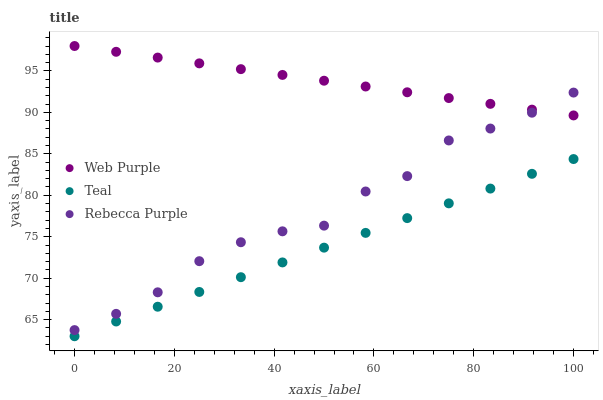Does Teal have the minimum area under the curve?
Answer yes or no. Yes. Does Web Purple have the maximum area under the curve?
Answer yes or no. Yes. Does Rebecca Purple have the minimum area under the curve?
Answer yes or no. No. Does Rebecca Purple have the maximum area under the curve?
Answer yes or no. No. Is Teal the smoothest?
Answer yes or no. Yes. Is Rebecca Purple the roughest?
Answer yes or no. Yes. Is Rebecca Purple the smoothest?
Answer yes or no. No. Is Teal the roughest?
Answer yes or no. No. Does Teal have the lowest value?
Answer yes or no. Yes. Does Rebecca Purple have the lowest value?
Answer yes or no. No. Does Web Purple have the highest value?
Answer yes or no. Yes. Does Rebecca Purple have the highest value?
Answer yes or no. No. Is Teal less than Rebecca Purple?
Answer yes or no. Yes. Is Rebecca Purple greater than Teal?
Answer yes or no. Yes. Does Web Purple intersect Rebecca Purple?
Answer yes or no. Yes. Is Web Purple less than Rebecca Purple?
Answer yes or no. No. Is Web Purple greater than Rebecca Purple?
Answer yes or no. No. Does Teal intersect Rebecca Purple?
Answer yes or no. No. 